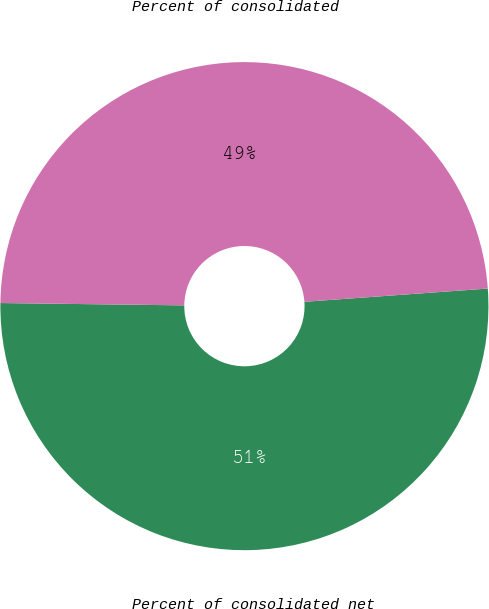<chart> <loc_0><loc_0><loc_500><loc_500><pie_chart><fcel>Percent of consolidated net<fcel>Percent of consolidated<nl><fcel>51.35%<fcel>48.65%<nl></chart> 